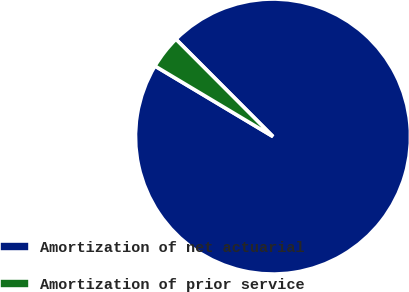Convert chart to OTSL. <chart><loc_0><loc_0><loc_500><loc_500><pie_chart><fcel>Amortization of net actuarial<fcel>Amortization of prior service<nl><fcel>96.05%<fcel>3.95%<nl></chart> 